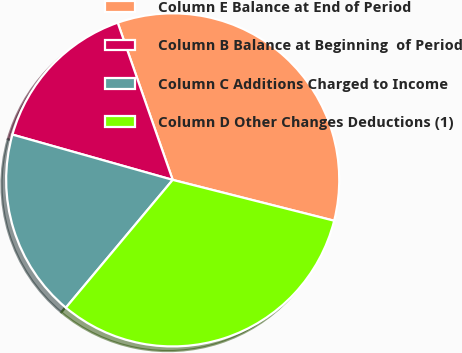<chart> <loc_0><loc_0><loc_500><loc_500><pie_chart><fcel>Column E Balance at End of Period<fcel>Column B Balance at Beginning  of Period<fcel>Column C Additions Charged to Income<fcel>Column D Other Changes Deductions (1)<nl><fcel>34.3%<fcel>15.26%<fcel>18.3%<fcel>32.14%<nl></chart> 